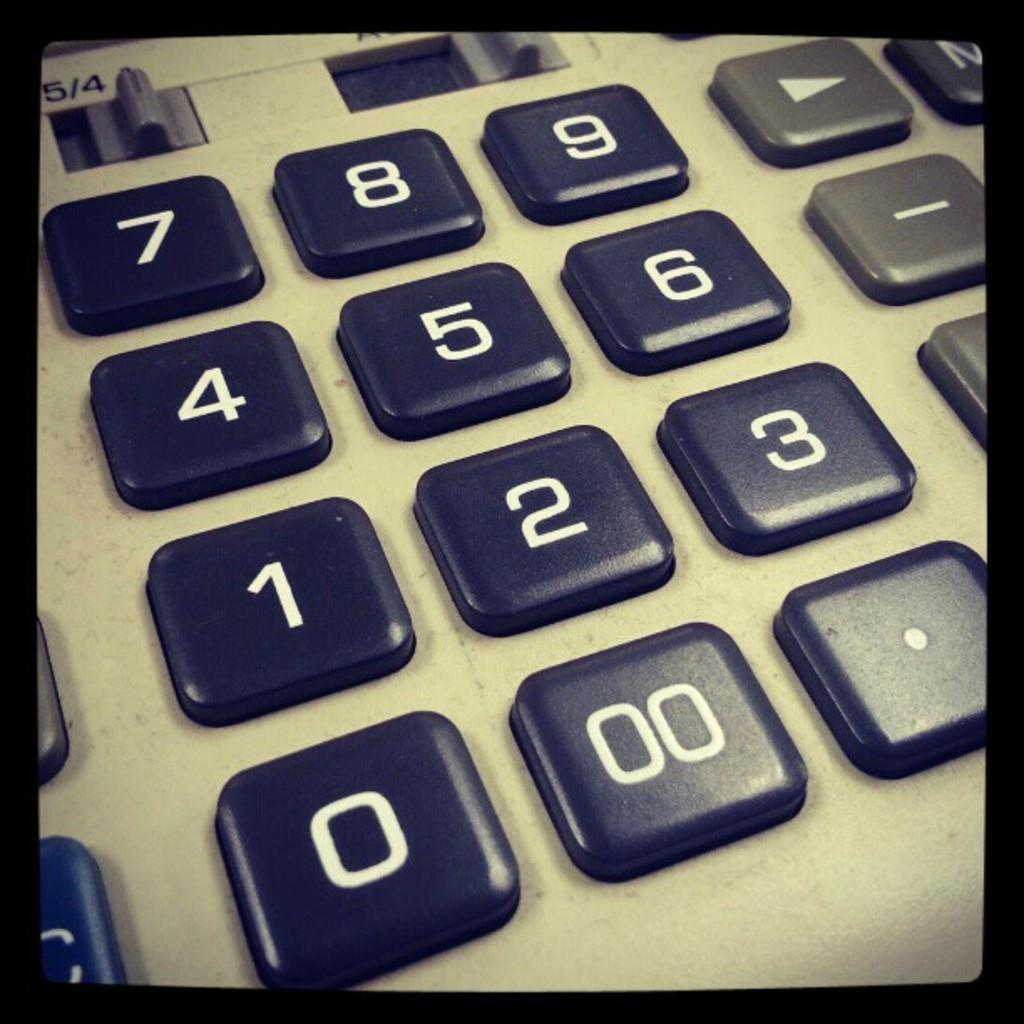<image>
Describe the image concisely. A vintage style calculator with the numbers 0-9 on it. 